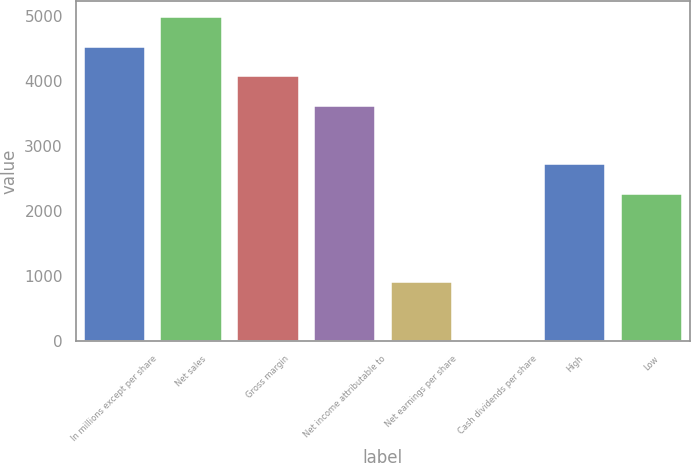Convert chart to OTSL. <chart><loc_0><loc_0><loc_500><loc_500><bar_chart><fcel>In millions except per share<fcel>Net sales<fcel>Gross margin<fcel>Net income attributable to<fcel>Net earnings per share<fcel>Cash dividends per share<fcel>High<fcel>Low<nl><fcel>4525<fcel>4977.45<fcel>4072.55<fcel>3620.1<fcel>905.4<fcel>0.5<fcel>2715.2<fcel>2262.75<nl></chart> 